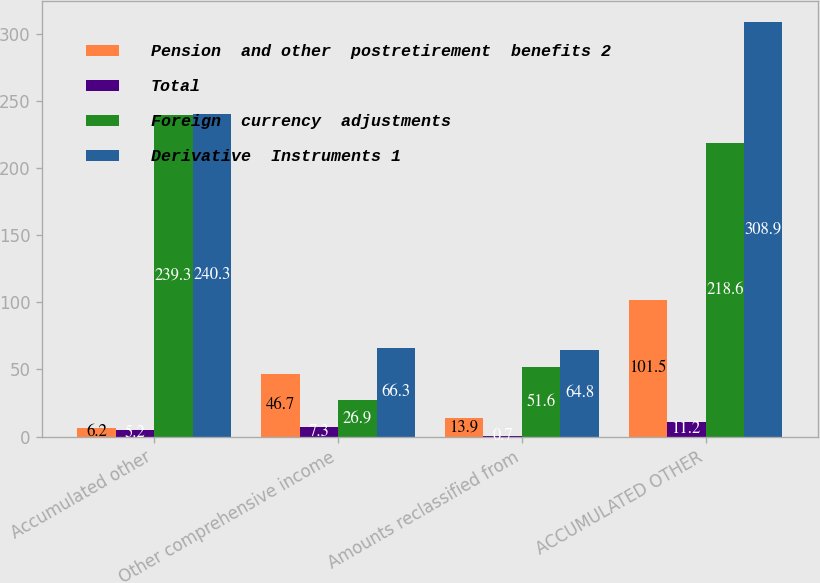Convert chart. <chart><loc_0><loc_0><loc_500><loc_500><stacked_bar_chart><ecel><fcel>Accumulated other<fcel>Other comprehensive income<fcel>Amounts reclassified from<fcel>ACCUMULATED OTHER<nl><fcel>Pension  and other  postretirement  benefits 2<fcel>6.2<fcel>46.7<fcel>13.9<fcel>101.5<nl><fcel>Total<fcel>5.2<fcel>7.3<fcel>0.7<fcel>11.2<nl><fcel>Foreign  currency  adjustments<fcel>239.3<fcel>26.9<fcel>51.6<fcel>218.6<nl><fcel>Derivative  Instruments 1<fcel>240.3<fcel>66.3<fcel>64.8<fcel>308.9<nl></chart> 